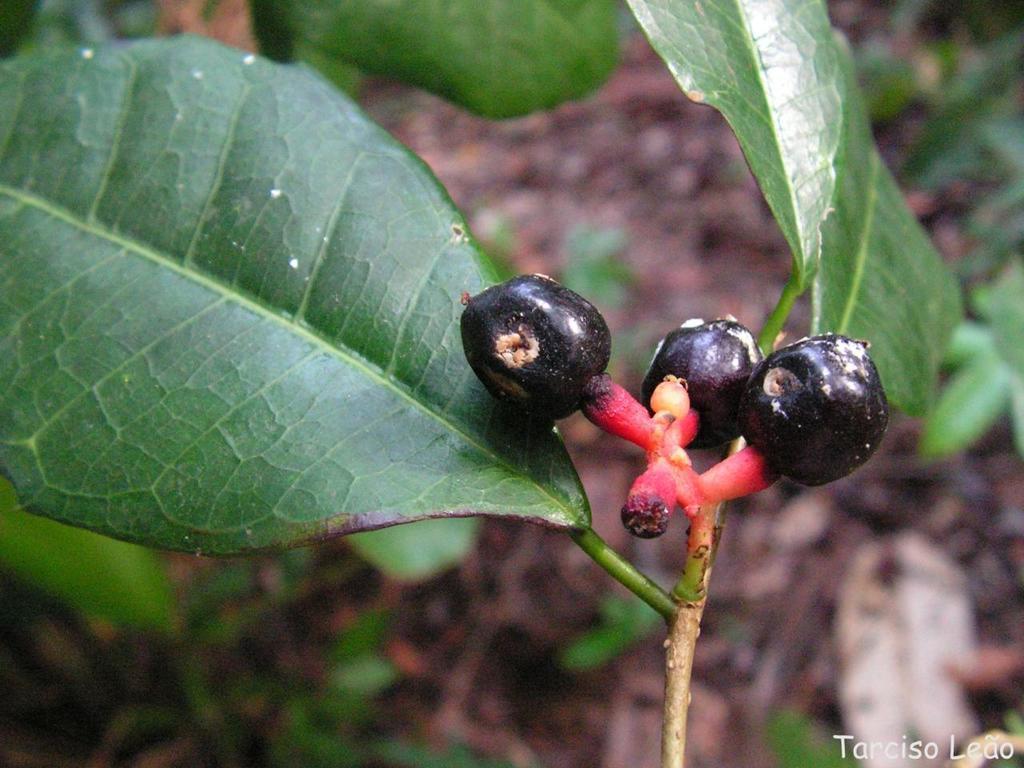Could you give a brief overview of what you see in this image? In this image we can see fruits, a stem and leaf. We can see a watermark in the bottom right corner of this image. 